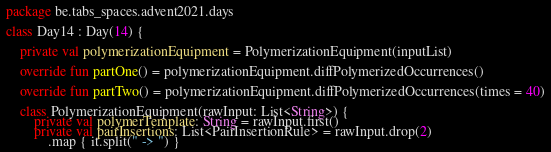Convert code to text. <code><loc_0><loc_0><loc_500><loc_500><_Kotlin_>package be.tabs_spaces.advent2021.days

class Day14 : Day(14) {

    private val polymerizationEquipment = PolymerizationEquipment(inputList)

    override fun partOne() = polymerizationEquipment.diffPolymerizedOccurrences()

    override fun partTwo() = polymerizationEquipment.diffPolymerizedOccurrences(times = 40)

    class PolymerizationEquipment(rawInput: List<String>) {
        private val polymerTemplate: String = rawInput.first()
        private val pairInsertions: List<PairInsertionRule> = rawInput.drop(2)
            .map { it.split(" -> ") }</code> 